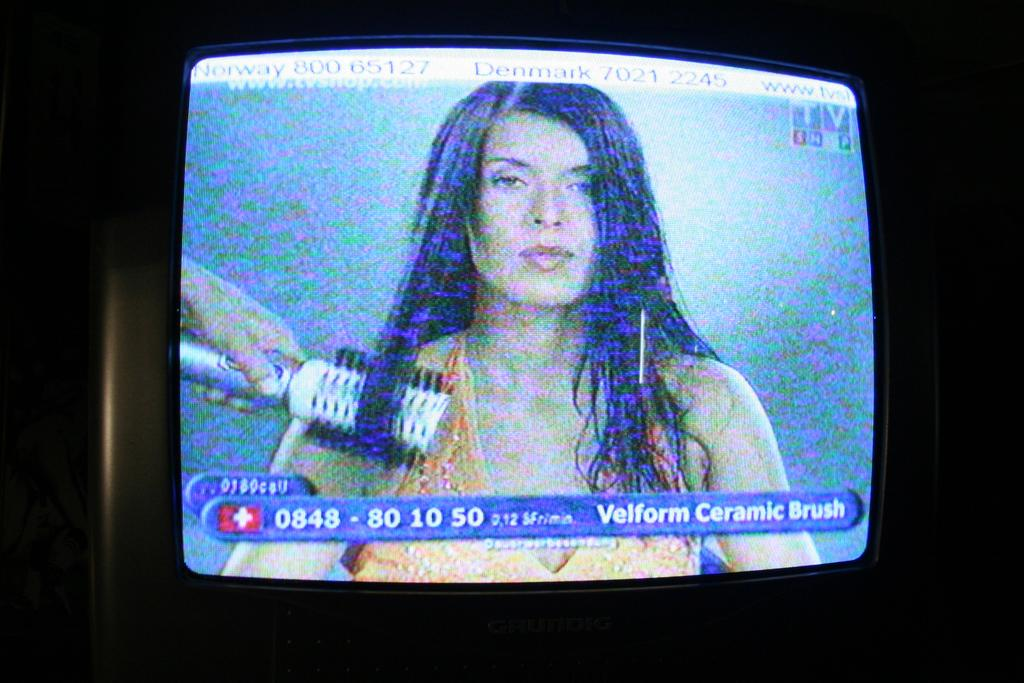What is the main subject of the image? There is a screen in the image. What can be seen on the screen? A woman is visible on the screen. What is the woman on the screen holding? The woman on the screen is holding an object in her hand. How would you describe the overall lighting in the image? The background of the image is dark. Can you see any waves crashing on the shore in the image? There are no waves or shore visible in the image; it features a screen with a woman holding an object. 